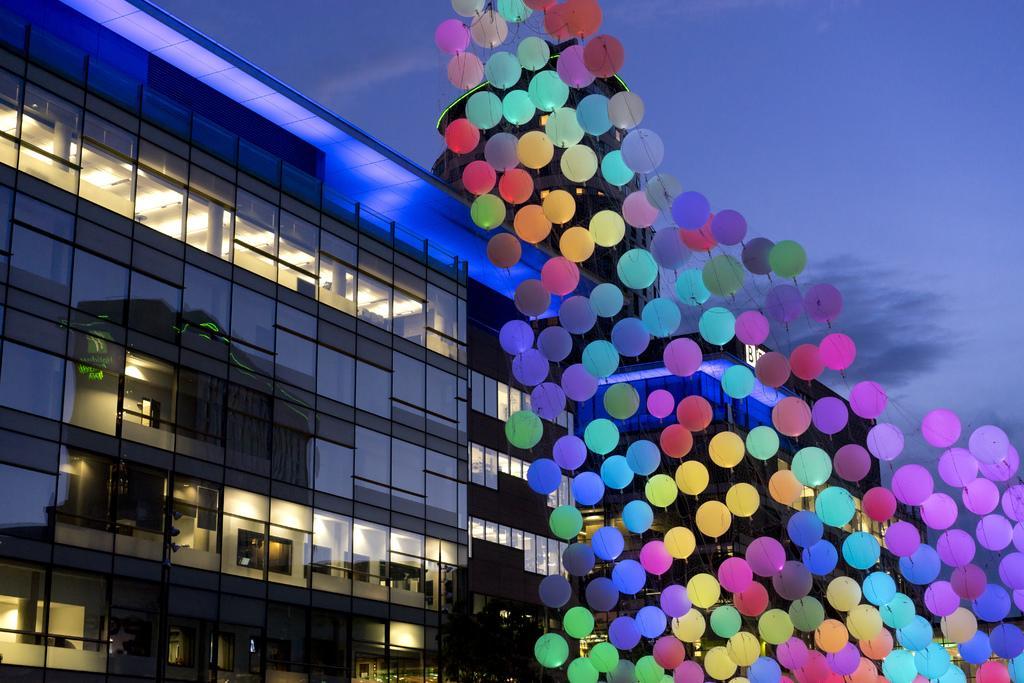In one or two sentences, can you explain what this image depicts? This picture is clicked outside. On the right we can see many number of balloons. On the left there is a building and we can see the windows of the building. In the background there is a sky. 